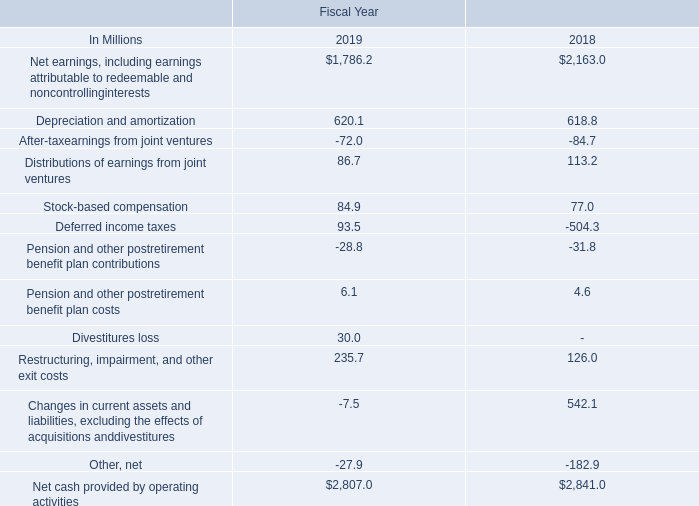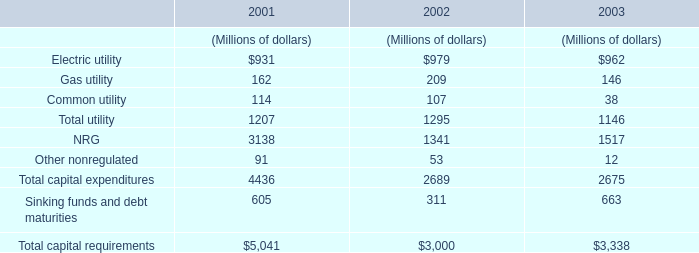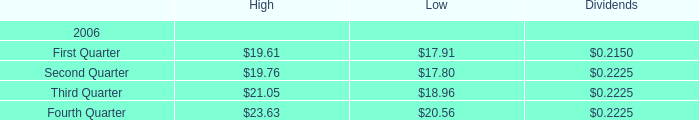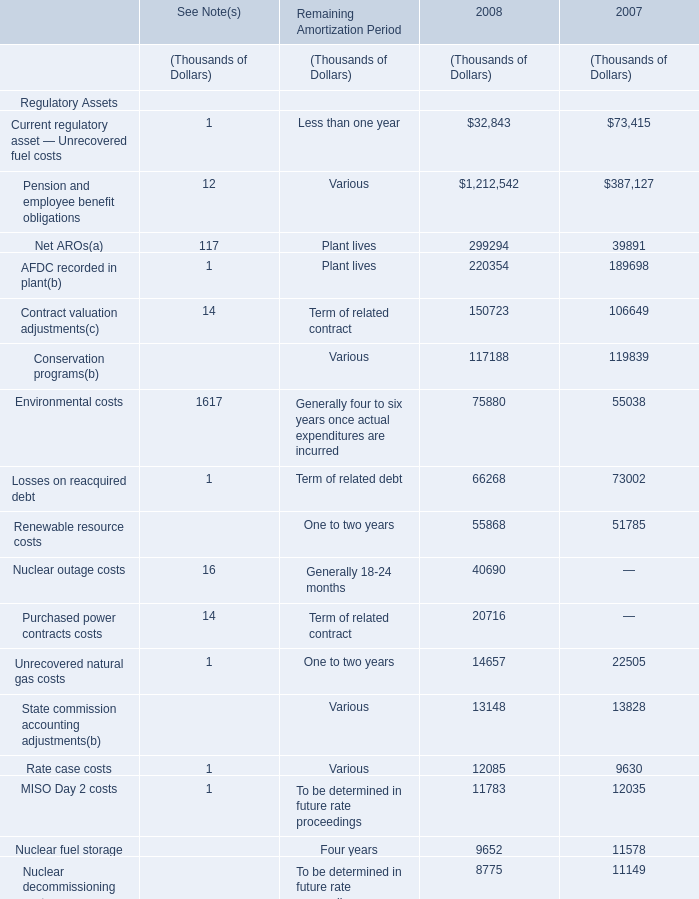What is the growing rate of Rate case costs in the year with the most Renewable resource costs? 
Computations: ((12085 - 9630) / 9630)
Answer: 0.25493. 